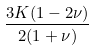Convert formula to latex. <formula><loc_0><loc_0><loc_500><loc_500>\frac { 3 K ( 1 - 2 \nu ) } { 2 ( 1 + \nu ) }</formula> 